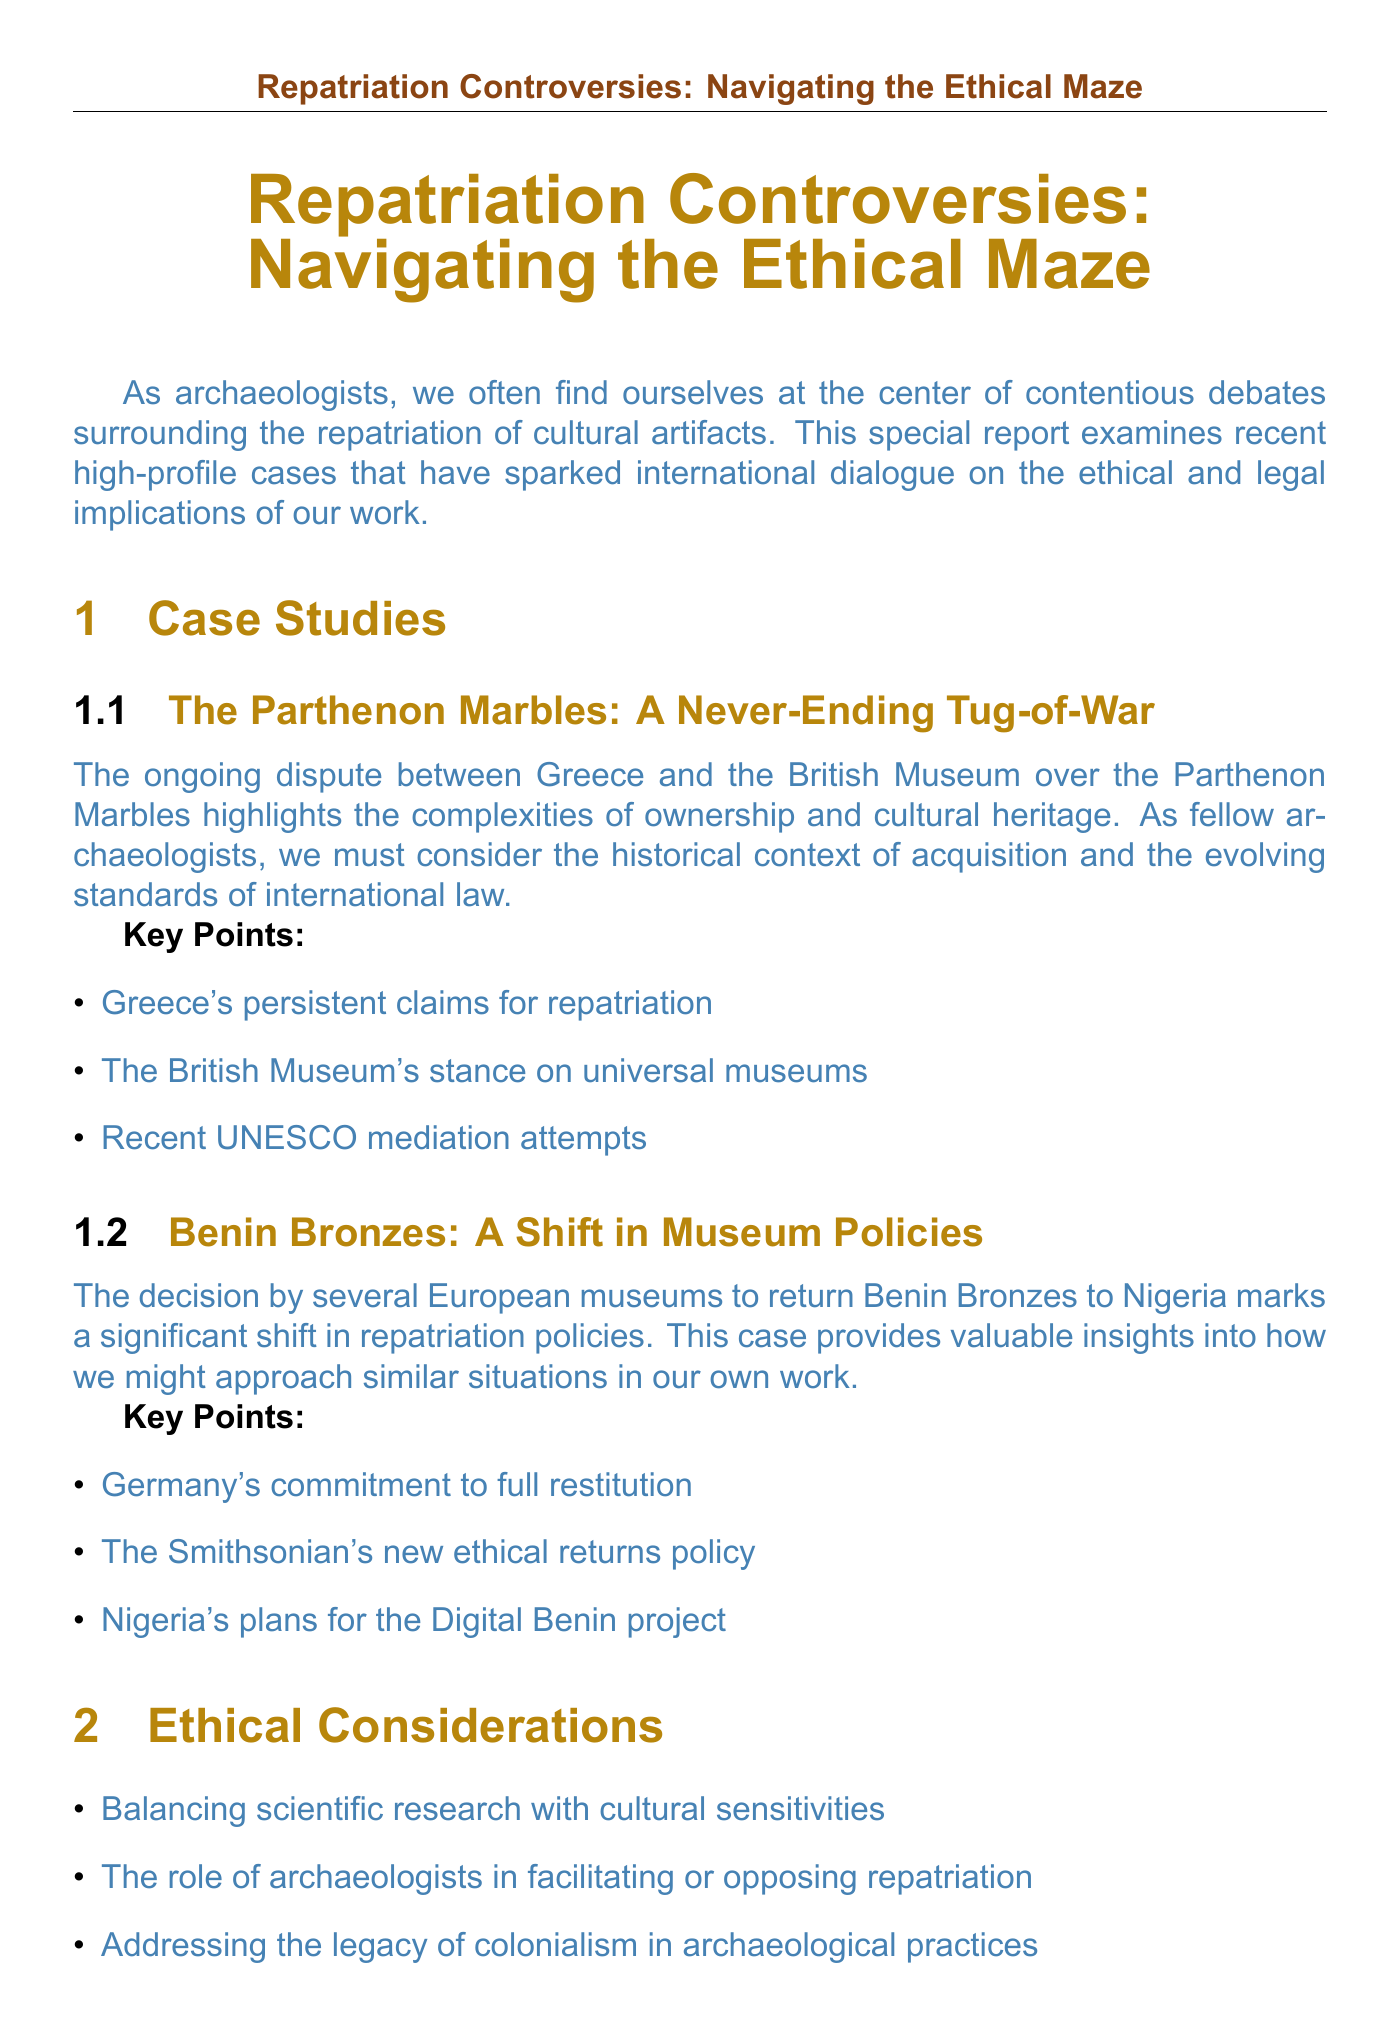What is the title of the newsletter? The title of the newsletter is explicitly stated at the beginning of the document.
Answer: Repatriation Controversies: Navigating the Ethical Maze Who authored the quote in the Expert Opinion section? The document provides the name of the expert who authored the quote.
Answer: Dr. Sarah Johnson What significant shift is discussed in relation to the Benin Bronzes? This information can be found in the description of the Benin Bronzes case study.
Answer: A shift in museum policies What year is associated with the UNESCO Convention mentioned in the Legal Implications section? The document explicitly mentions the year related to the UNESCO Convention.
Answer: 1970 What is one key point mentioned about Greece's claims? Key points related to Greece's claims are found in the Parthenon Marbles case study.
Answer: Greece's persistent claims for repatriation What does the document suggest as a strategy to stay ahead in the repatriation landscape? Strategies are summarized in the Staying Ahead section of the newsletter.
Answer: Developing expertise in provenance research What role do archaeologists have in the repatriation debate according to the Ethical Considerations section? The role of archaeologists is listed among the ethical considerations in the document.
Answer: Facilitating or opposing repatriation What is the focus of the conclusion in the newsletter? The conclusion summarizes the main goal of the newsletter based on the discussions in the earlier sections.
Answer: Remaining informed and adaptable 